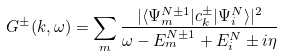<formula> <loc_0><loc_0><loc_500><loc_500>G ^ { \pm } ( { k } , \omega ) = \sum _ { m } \frac { | \langle \Psi ^ { N \pm 1 } _ { m } | c ^ { \pm } _ { k } | \Psi ^ { N } _ { i } \rangle | ^ { 2 } } { \omega - E _ { m } ^ { N \pm 1 } + E ^ { N } _ { i } \pm i \eta }</formula> 